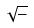<formula> <loc_0><loc_0><loc_500><loc_500>\sqrt { - }</formula> 